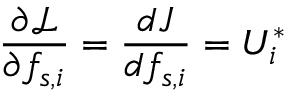Convert formula to latex. <formula><loc_0><loc_0><loc_500><loc_500>\frac { \partial \mathcal { L } } { \partial f _ { s , i } } = \frac { d J } { d f _ { s , i } } = U _ { i } ^ { * }</formula> 